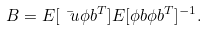<formula> <loc_0><loc_0><loc_500><loc_500>B = E [ \bar { \ u } \phi b ^ { T } ] E [ \phi b \phi b ^ { T } ] ^ { - 1 } .</formula> 